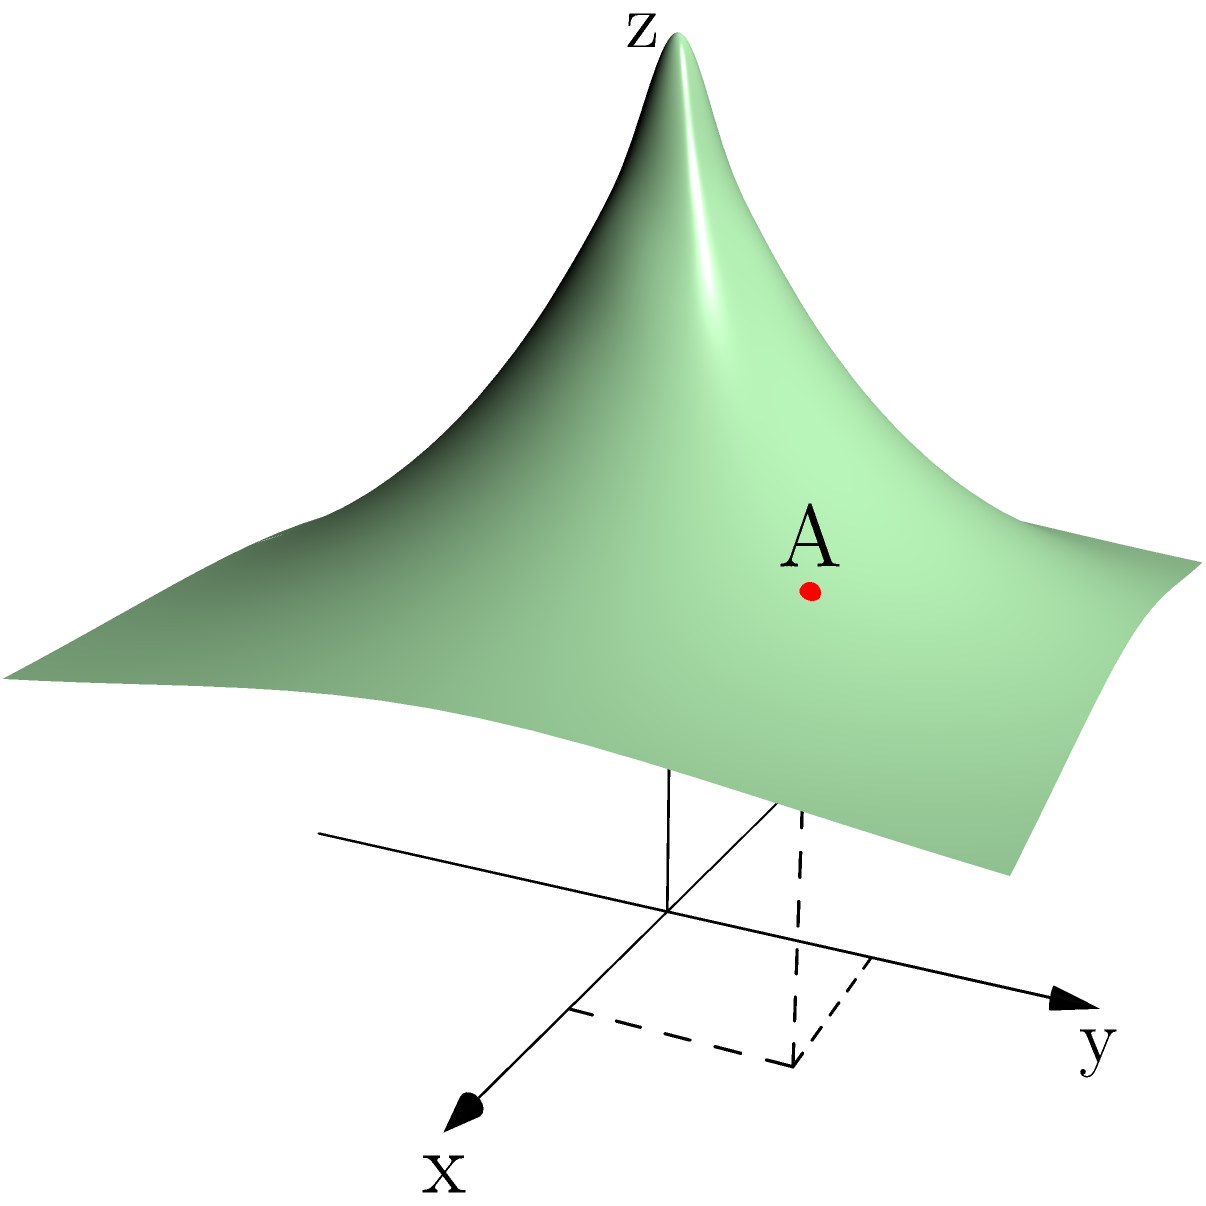In translating a key storyboard sketch into a 3D coordinate space for CGI integration, you've identified a crucial point A on a character's face. Given that A is located at coordinates $(1, 1, z)$ on the surface defined by $z = 0.5 + e^{-\sqrt{x^2 + y^2}}$, what is the z-coordinate of point A? To find the z-coordinate of point A, we need to follow these steps:

1) The surface is defined by the equation $z = 0.5 + e^{-\sqrt{x^2 + y^2}}$.

2) We know that point A has x and y coordinates of 1, so we need to calculate:
   $z = 0.5 + e^{-\sqrt{1^2 + 1^2}}$

3) Simplify the expression under the square root:
   $z = 0.5 + e^{-\sqrt{2}}$

4) Calculate the square root:
   $z = 0.5 + e^{-1.4142...}$

5) Calculate the exponential:
   $z = 0.5 + 0.2431...$

6) Sum the terms:
   $z = 0.7431...$

Therefore, the z-coordinate of point A is approximately 0.7431.
Answer: $0.7431$ 